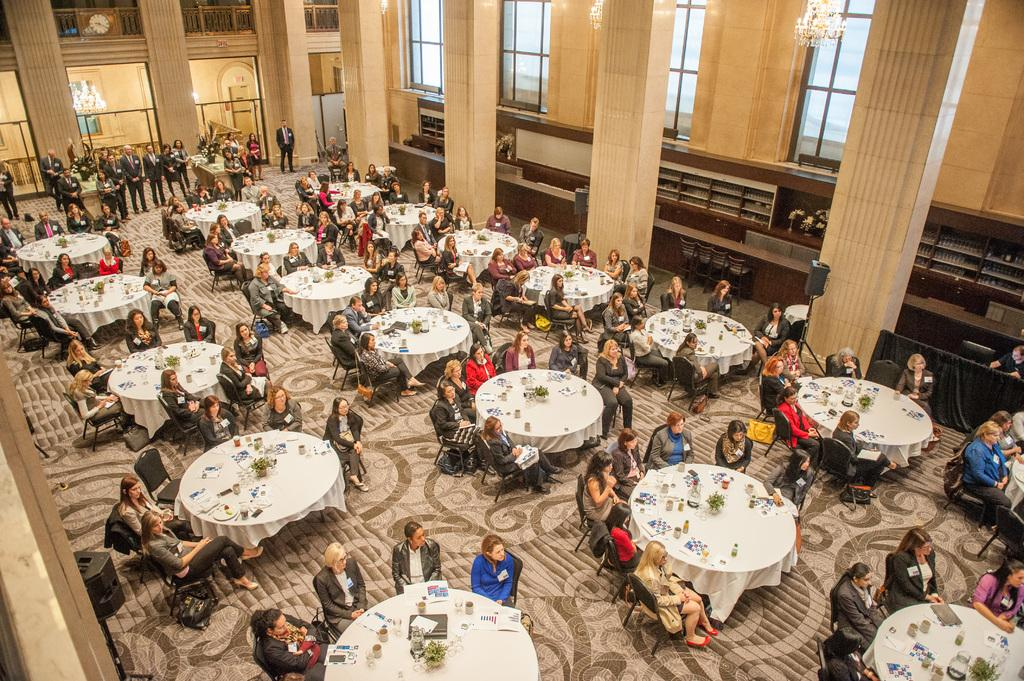What are the people in the image doing? The people in the image are sitting on chairs. What is in front of the sitting people? There is a table in front of the sitting people. Are there any other people in the image? Yes, there are people standing in the image. What architectural feature can be seen in the image? There is a pillar in the image. What type of bells can be heard ringing in the image? There are no bells present in the image, and therefore no sound can be heard. 